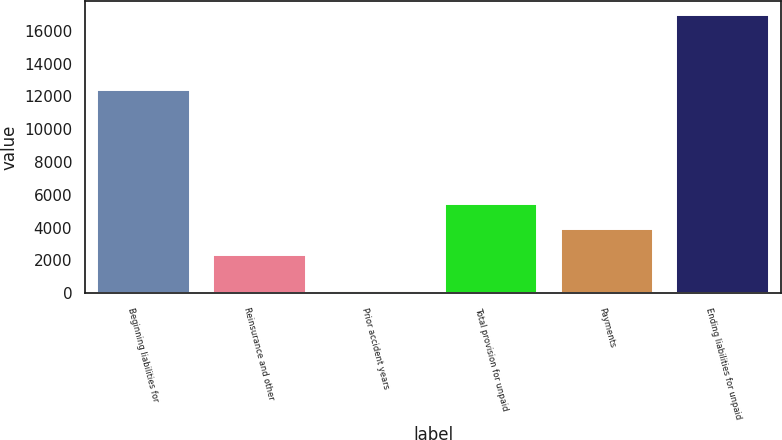Convert chart to OTSL. <chart><loc_0><loc_0><loc_500><loc_500><bar_chart><fcel>Beginning liabilities for<fcel>Reinsurance and other<fcel>Prior accident years<fcel>Total provision for unpaid<fcel>Payments<fcel>Ending liabilities for unpaid<nl><fcel>12366<fcel>2361<fcel>125<fcel>5423.4<fcel>3892.2<fcel>16959.6<nl></chart> 